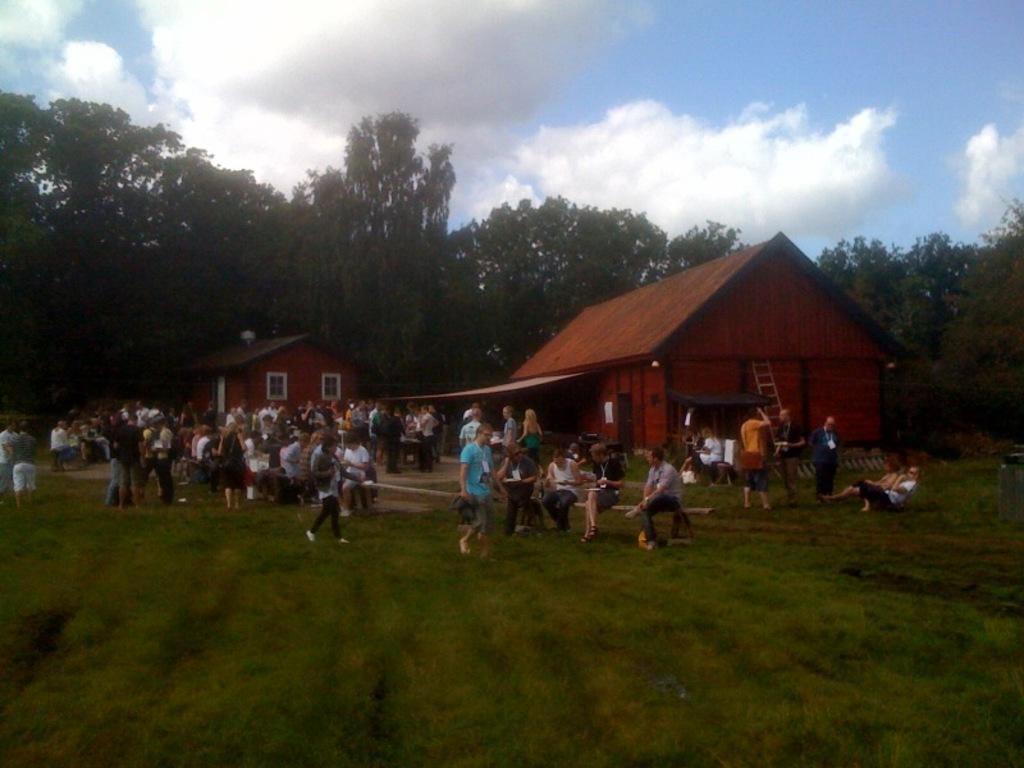What type of vegetation can be seen in the image? There are trees in the image. What type of structures are visible in the image? There are houses in the image. What living beings can be seen in the image? There are people in the image. What type of ground cover is present in the image? There is grass in the image. What additional object can be seen in the image? There is a ladder in the image. What is the condition of the sky in the image? The sky is cloudy in the image. What type of land cover is present in the image? The land is covered with grass. What activity are some people engaged in within the image? Some people are walking in the image. What type of beast is pulling the plough in the image? There is no plough or beast present in the image. What day of the week is depicted in the image? The image does not depict a specific day of the week. 